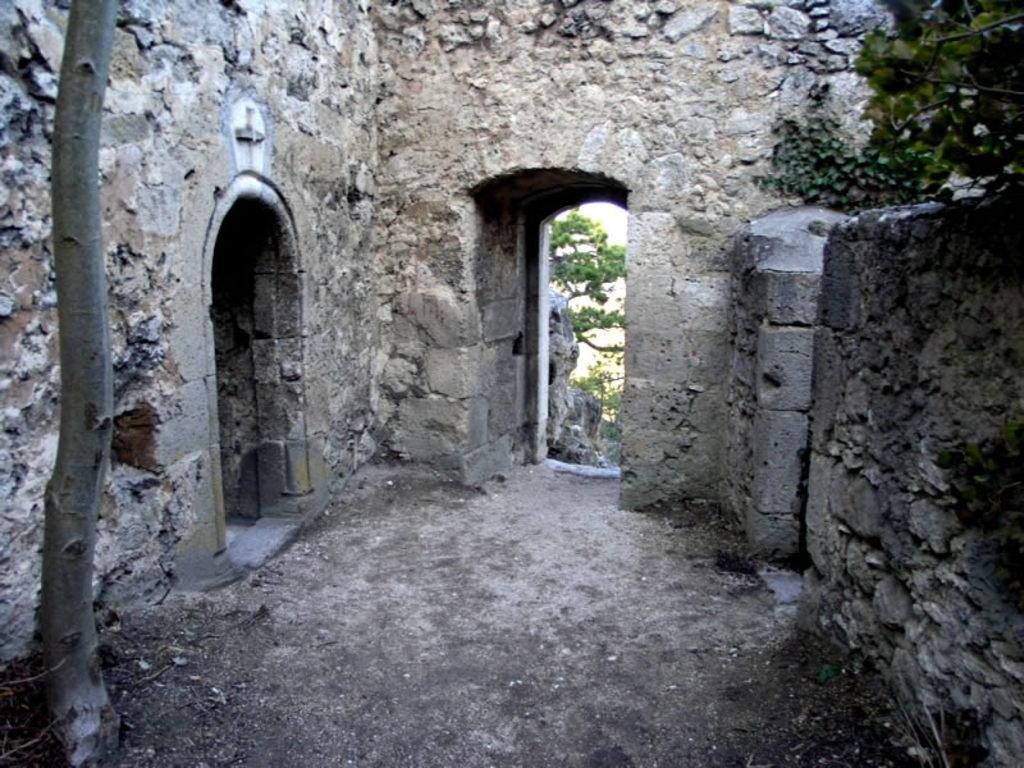What type of natural elements can be seen in the image? There are trees in the image. What man-made structure is present in the image? There is a rock wall in the image. What type of division can be seen in the image? There is no division present in the image; it features trees and a rock wall. What type of oven is visible in the image? There is no oven present in the image. 